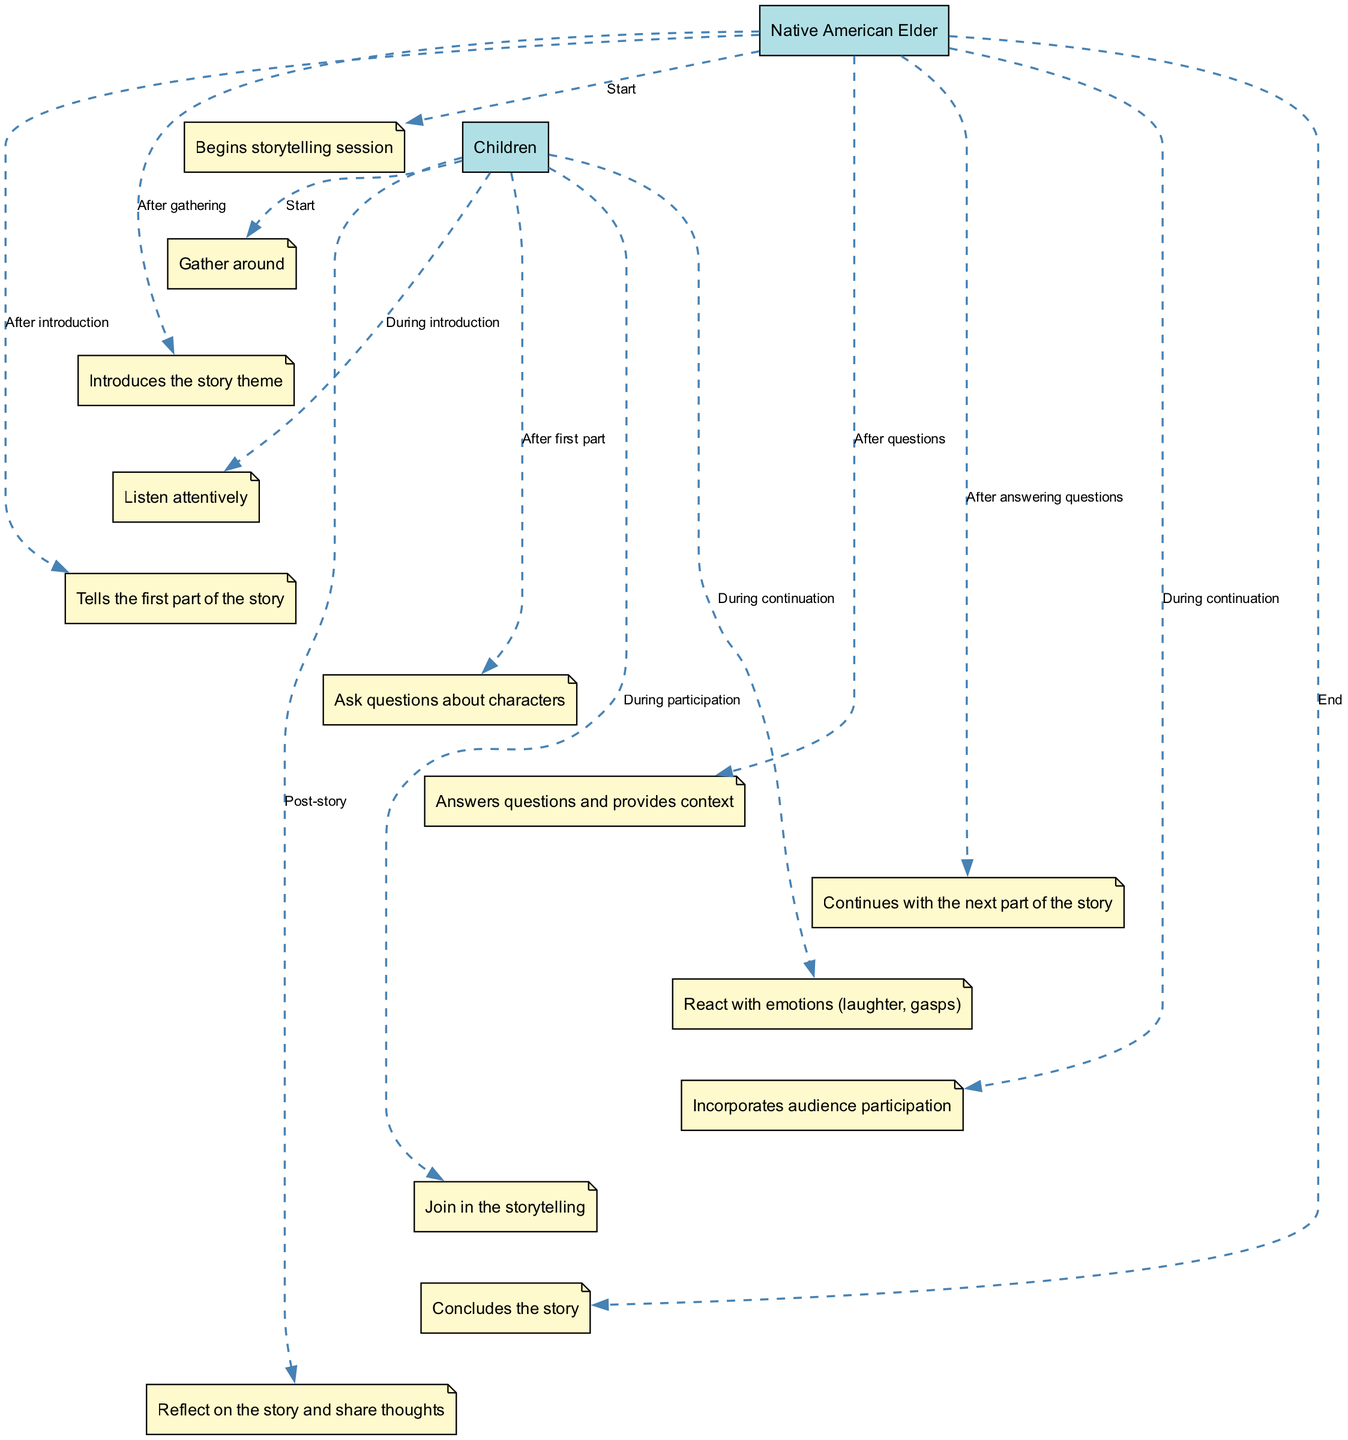What is the first action performed by the Native American Elder? The diagram shows that the first action listed for the Native American Elder is "Begins storytelling session". This is the initial action that sets the stage for the storytelling activity.
Answer: Begins storytelling session How many participants are involved in the storytelling session? By examining the diagram, we can identify two main participants: the Native American Elder and the Children. This means there are a total of two participants involved in this sequence.
Answer: 2 What do the Children do immediately after gathering? According to the diagram, after the Children gather around, they "Listen attentively". This shows their engagement right at the beginning of the storytelling session.
Answer: Listen attentively What action follows the Children's questions after the first part of the story? The diagram indicates that after the Children ask questions about the characters, the next action performed is that the Native American Elder "Answers questions and provides context". This shows the interactive nature of the storytelling.
Answer: Answers questions and provides context How do the Children react during the continuation of the story? The diagram illustrates that during the continuation of the story, the Children "React with emotions (laughter, gasps)". This indicates their emotional engagement and response to the storytelling.
Answer: React with emotions (laughter, gasps) Which action by the Children indicates their participation in the story? The diagram states that during audience participation, the Children "Join in the storytelling". This signifies their active involvement in the session.
Answer: Join in the storytelling What is the last action taken by the Native American Elder in the sequence? The final action listed for the Native American Elder is "Concludes the story". This marks the end of the storytelling session, wrapping up the activities.
Answer: Concludes the story What happens after the story concludes? According to the diagram, after the story concludes, the Children "Reflect on the story and share thoughts". This shows the importance of reflection and discussion after storytelling.
Answer: Reflect on the story and share thoughts 